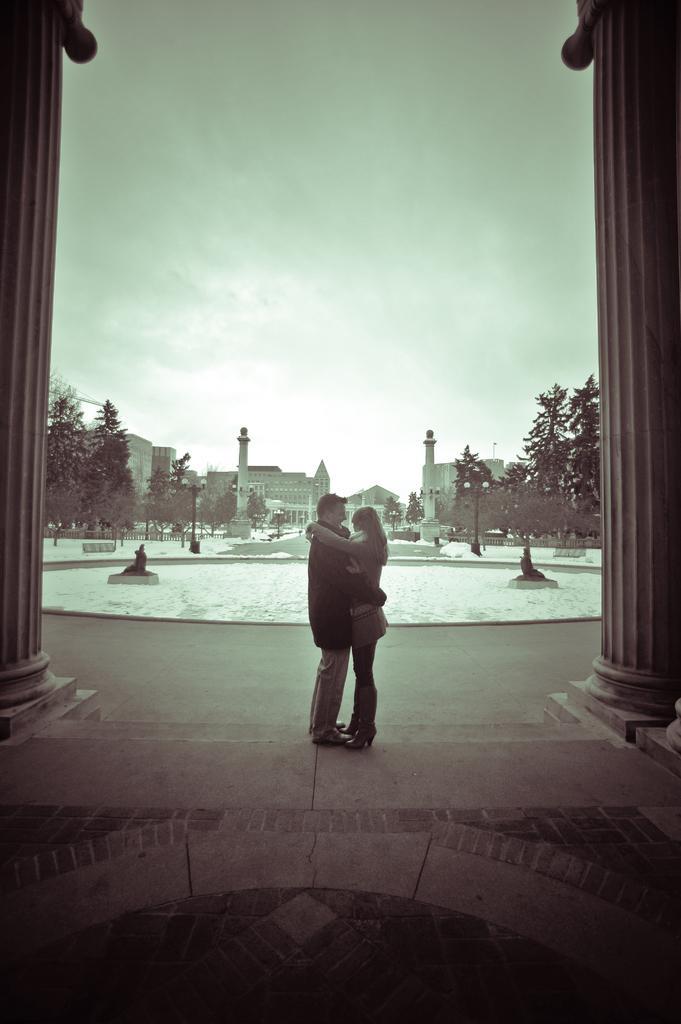In one or two sentences, can you explain what this image depicts? This is an edited image. There are buildings in the middle. There are trees in the middle. There are two persons standing in the middle. There is sky at the top. 